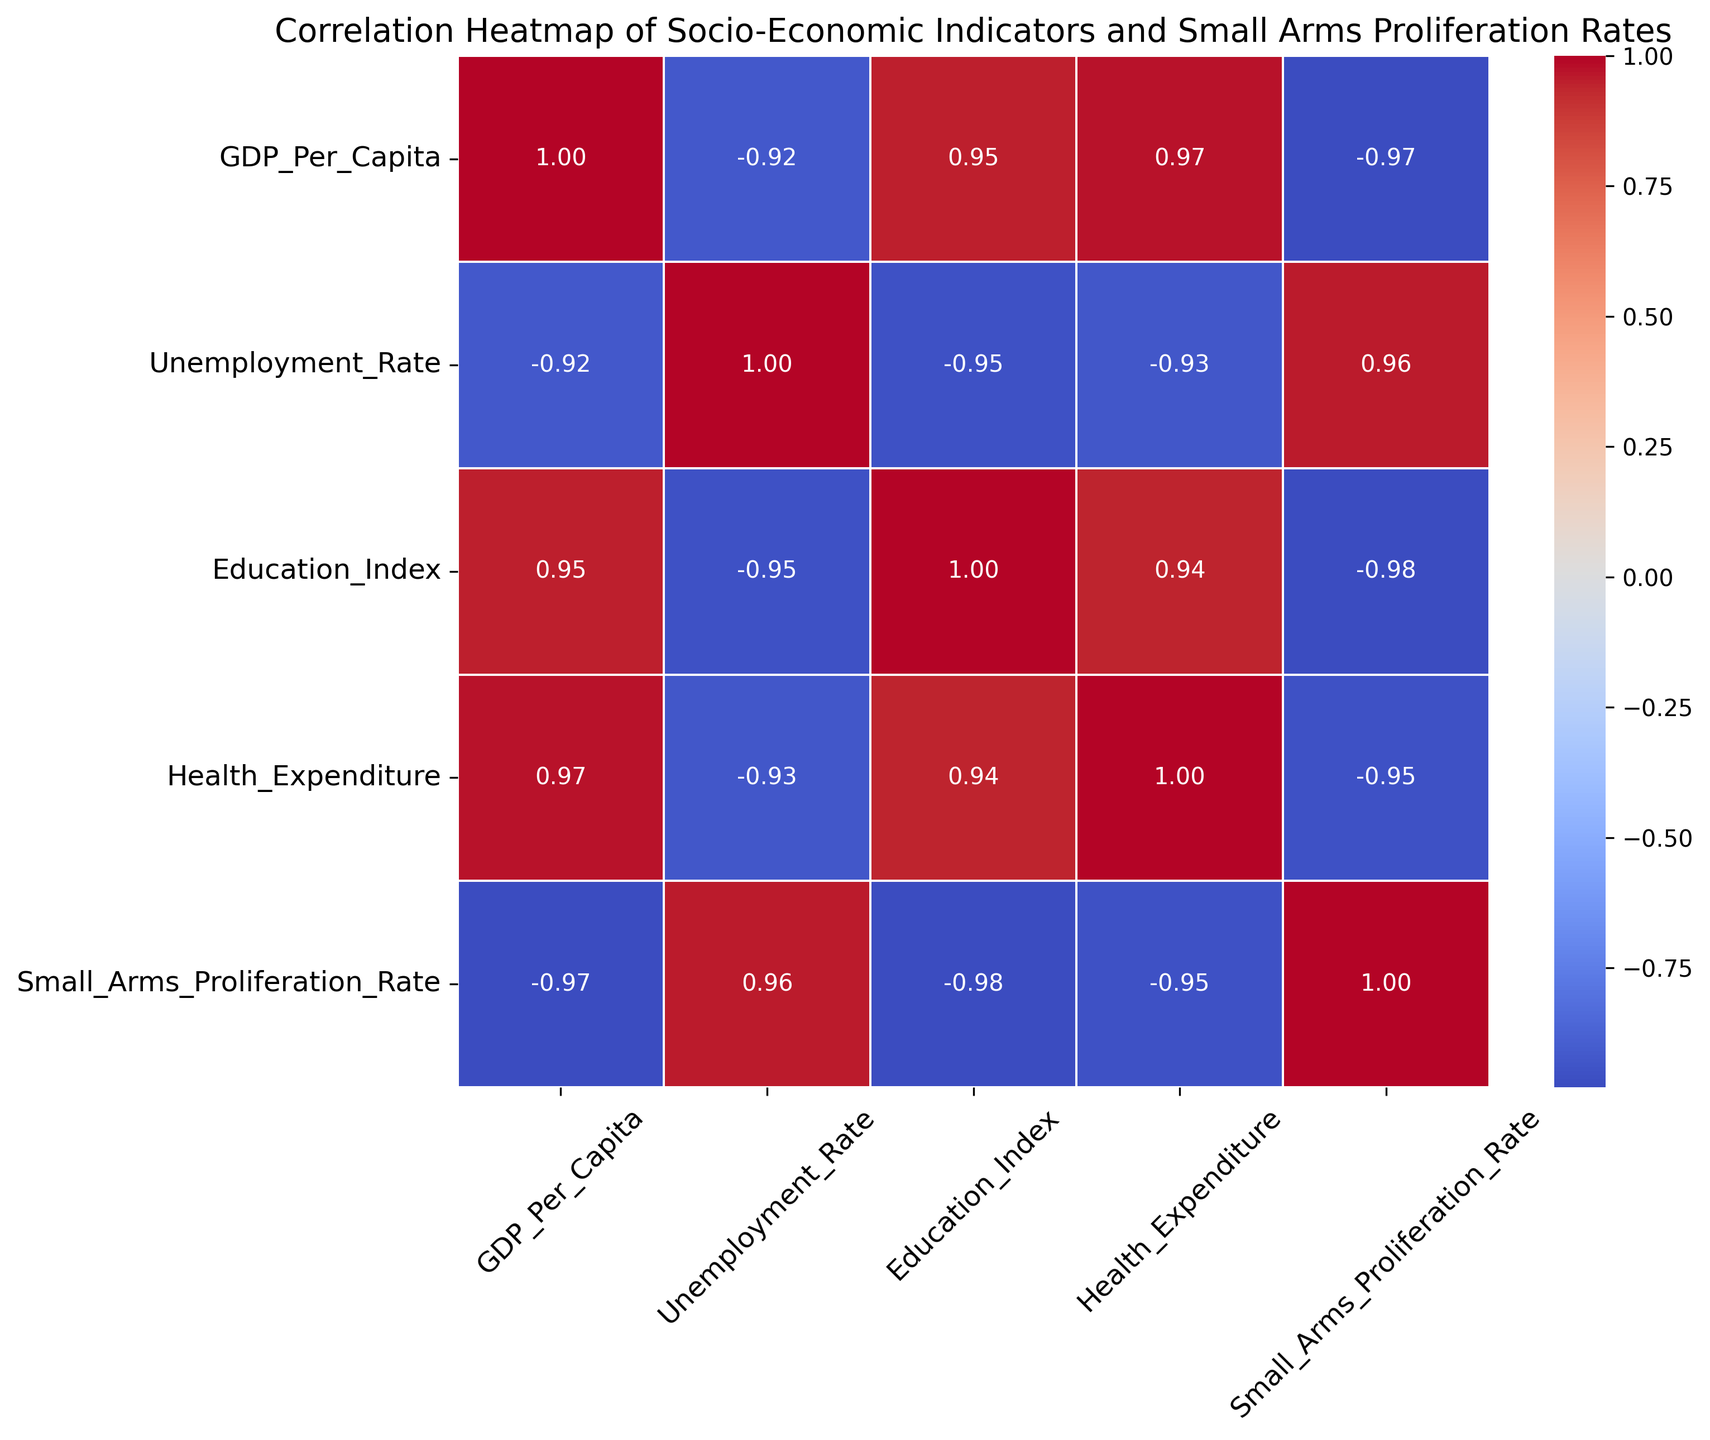What socio-economic indicator has the highest positive correlation with Small Arms Proliferation Rate? To identify the socio-economic indicator with the highest positive correlation with Small Arms Proliferation Rate, locate the 'Small_Arms_Proliferation_Rate' row in the heatmap. The cell with the highest positive value in this row represents the strongest positive correlation.
Answer: Unemployment Rate Which indicator has a stronger correlation with Small Arms Proliferation Rate, GDP Per Capita or Education Index? Compare the correlation values of 'Small_Arms_Proliferation_Rate' with 'GDP_Per_Capita' and 'Education_Index' from the figure. The larger absolute value indicates the stronger correlation.
Answer: Education Index What can be inferred about the relationship between Conflict Intensity and Small Arms Proliferation Rate based on the heatmap? Check the correlation value between 'Conflict_Intensity' and 'Small_Arms_Proliferation_Rate'. A positive value implies direct correlation (as one increases, so does the other), while a negative value implies inverse correlation.
Answer: Positive correlation If we sum the correlations of Health Expenditure with Small Arms Proliferation Rate and Education Index, what is the result? Find the correlation values of 'Health_Expenditure' with 'Small_Arms_Proliferation_Rate' and 'Education_Index', then add them together. For example, if they are -0.70 and 0.85 respectively, the sum is -0.70 + 0.85 = 0.15.
Answer: -0.05 Which socio-economic indicator is most negatively correlated with Small Arms Proliferation Rate? To identify the socio-economic indicator most negatively correlated with 'Small_Arms_Proliferation_Rate', locate the 'Small_Arms_Proliferation_Rate' row and find the cell with the lowest value (most negative).
Answer: Health Expenditure Is GDP Per Capita positively or negatively correlated with Unemployment Rate? Check the correlation value between 'GDP_Per_Capita' and 'Unemployment_Rate'. A positive value indicates a positive correlation, while a negative value indicates a negative correlation.
Answer: Negatively correlated Which correlation value indicates the strongest relationship overall on the heatmap, and between which indicators is it? Look for the absolute highest value (closest to +1 or -1) on the entire heatmap to determine the strongest relationship. Note down the indicators involved in this strongest correlation.
Answer: Conflict Intensity and Small Arms Proliferation Rate 